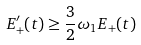<formula> <loc_0><loc_0><loc_500><loc_500>E _ { + } ^ { \prime } ( t ) \geq \frac { 3 } { 2 } \omega _ { 1 } E _ { + } ( t )</formula> 